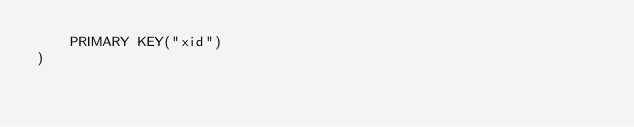<code> <loc_0><loc_0><loc_500><loc_500><_SQL_>	PRIMARY KEY("xid")
)</code> 